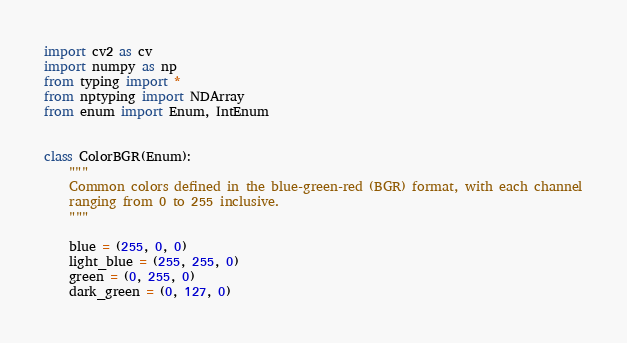Convert code to text. <code><loc_0><loc_0><loc_500><loc_500><_Python_>import cv2 as cv
import numpy as np
from typing import *
from nptyping import NDArray
from enum import Enum, IntEnum


class ColorBGR(Enum):
    """
    Common colors defined in the blue-green-red (BGR) format, with each channel
    ranging from 0 to 255 inclusive.
    """

    blue = (255, 0, 0)
    light_blue = (255, 255, 0)
    green = (0, 255, 0)
    dark_green = (0, 127, 0)</code> 